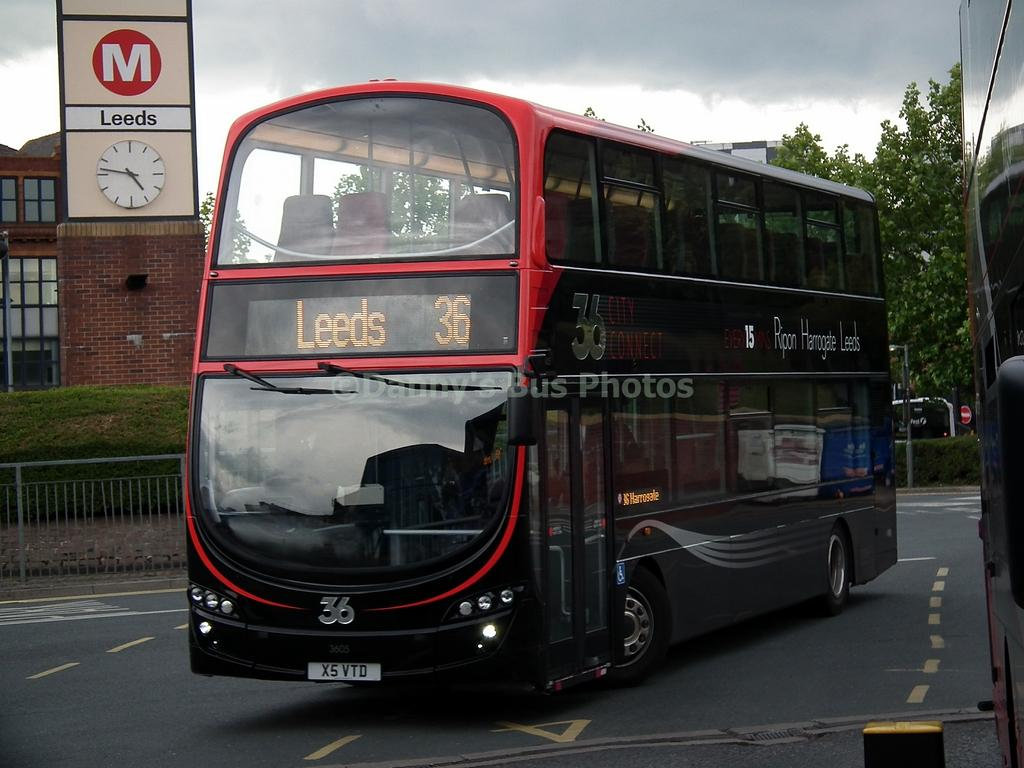What is the main subject of the image? The main subject of the image is a bus. What object can be seen on the left side of the image? There is a clock on the left side of the image. What type of surface is visible in the image? There is a road visible in the image. What type of cake is being served for dinner in the image? There is no cake or dinner present in the image; it features a bus and a clock. What angle is the bus tilted at in the image? The bus is not tilted at any angle in the image; it appears to be standing upright. 